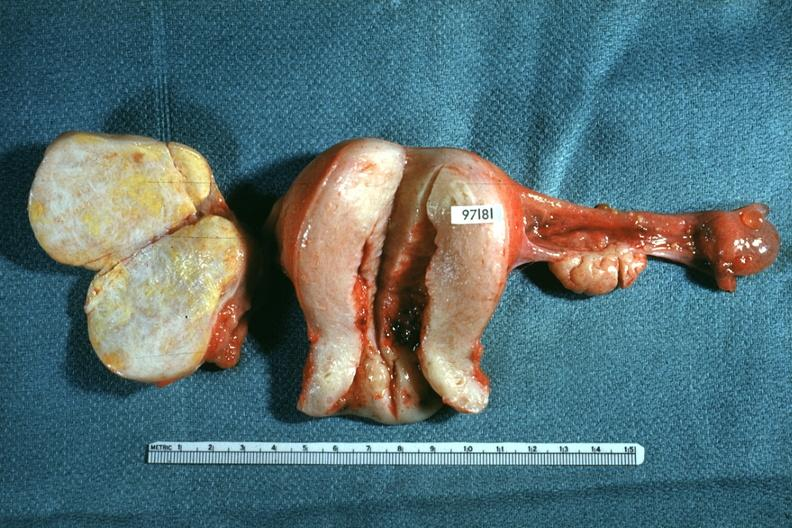how does this image show ovaries and uterus?
Answer the question using a single word or phrase. With tumor mass 